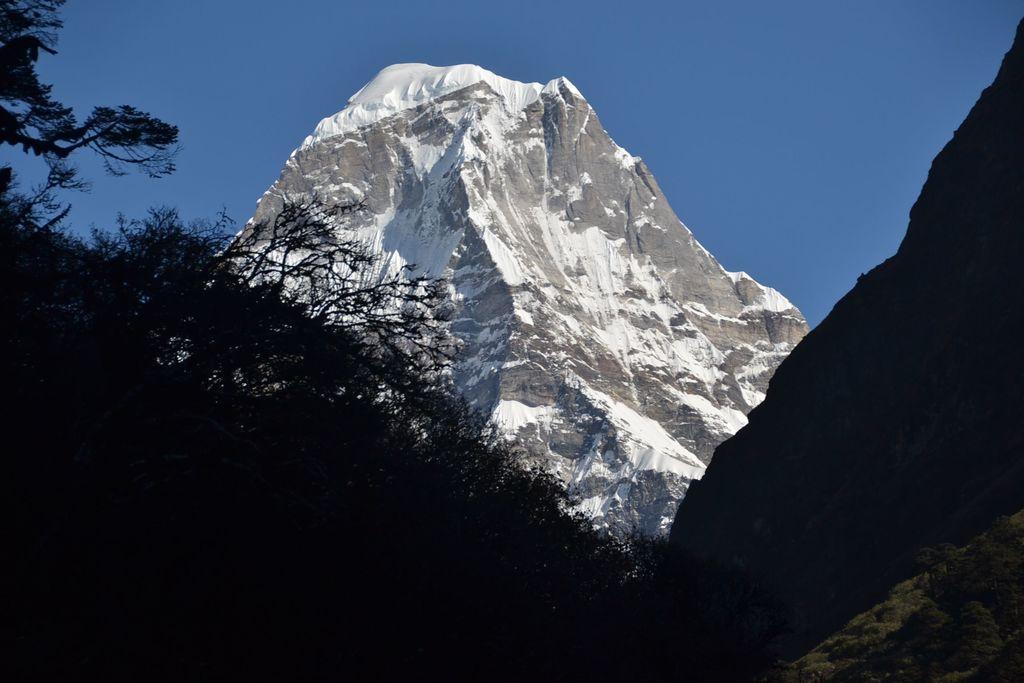Can you describe this image briefly? In this picture I can observe some trees. There is a mountain on which I can observe some snow. In the background there is a sky. 